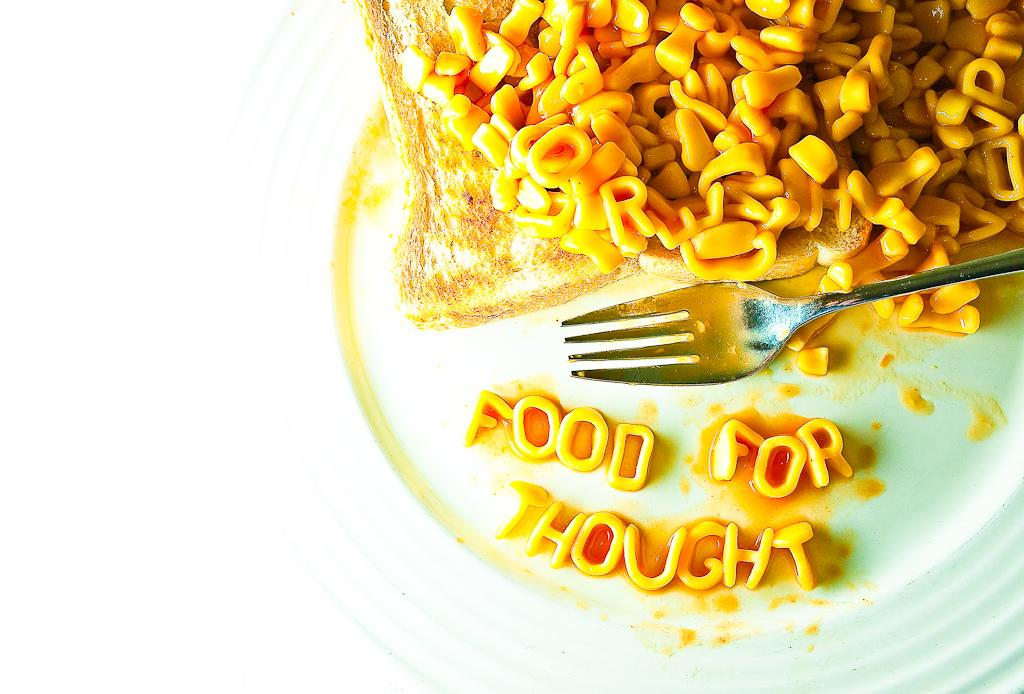What is on the plate that is visible in the image? There are food items on the plate in the image. What utensil is present on the plate? There is a fork on the plate. What color is the plate in the image? The plate is white. How many rings are stacked on the sock in the image? There are no rings or socks present in the image; it only features a white plate with food items and a fork. 